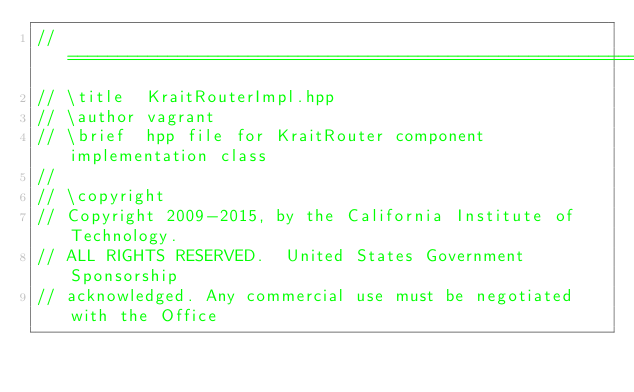<code> <loc_0><loc_0><loc_500><loc_500><_C++_>// ======================================================================
// \title  KraitRouterImpl.hpp
// \author vagrant
// \brief  hpp file for KraitRouter component implementation class
//
// \copyright
// Copyright 2009-2015, by the California Institute of Technology.
// ALL RIGHTS RESERVED.  United States Government Sponsorship
// acknowledged. Any commercial use must be negotiated with the Office</code> 